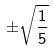Convert formula to latex. <formula><loc_0><loc_0><loc_500><loc_500>\pm \sqrt { \frac { 1 } { 5 } }</formula> 